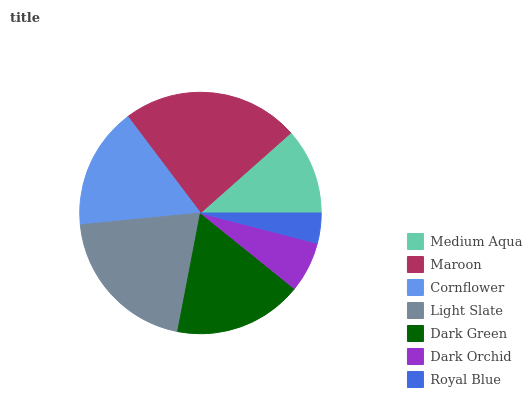Is Royal Blue the minimum?
Answer yes or no. Yes. Is Maroon the maximum?
Answer yes or no. Yes. Is Cornflower the minimum?
Answer yes or no. No. Is Cornflower the maximum?
Answer yes or no. No. Is Maroon greater than Cornflower?
Answer yes or no. Yes. Is Cornflower less than Maroon?
Answer yes or no. Yes. Is Cornflower greater than Maroon?
Answer yes or no. No. Is Maroon less than Cornflower?
Answer yes or no. No. Is Cornflower the high median?
Answer yes or no. Yes. Is Cornflower the low median?
Answer yes or no. Yes. Is Royal Blue the high median?
Answer yes or no. No. Is Maroon the low median?
Answer yes or no. No. 